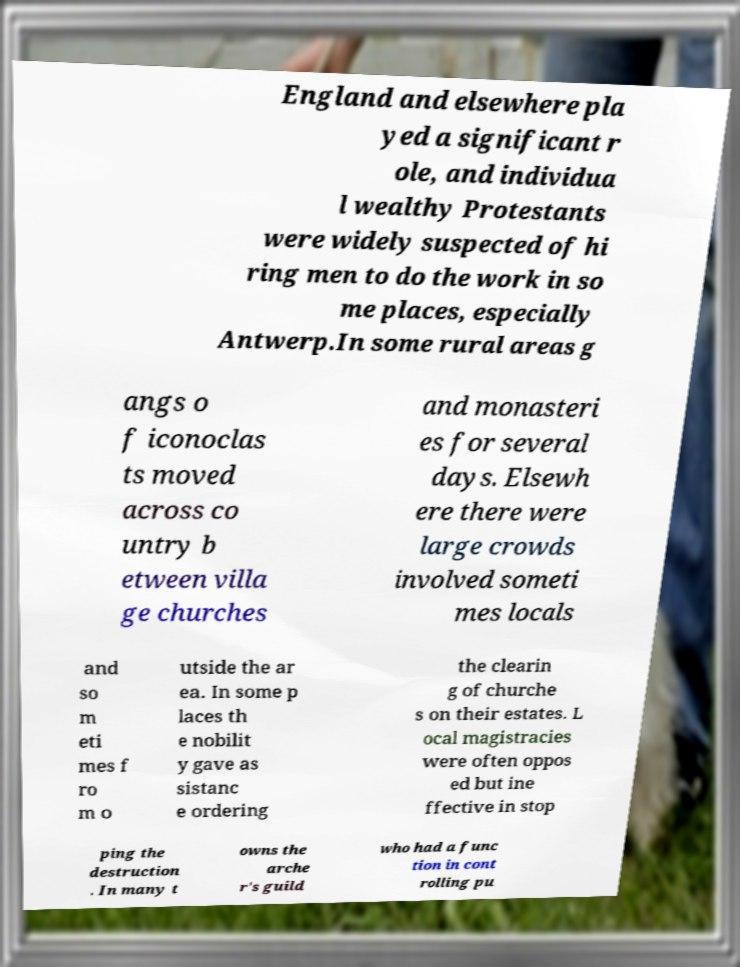Please identify and transcribe the text found in this image. England and elsewhere pla yed a significant r ole, and individua l wealthy Protestants were widely suspected of hi ring men to do the work in so me places, especially Antwerp.In some rural areas g angs o f iconoclas ts moved across co untry b etween villa ge churches and monasteri es for several days. Elsewh ere there were large crowds involved someti mes locals and so m eti mes f ro m o utside the ar ea. In some p laces th e nobilit y gave as sistanc e ordering the clearin g of churche s on their estates. L ocal magistracies were often oppos ed but ine ffective in stop ping the destruction . In many t owns the arche r's guild who had a func tion in cont rolling pu 